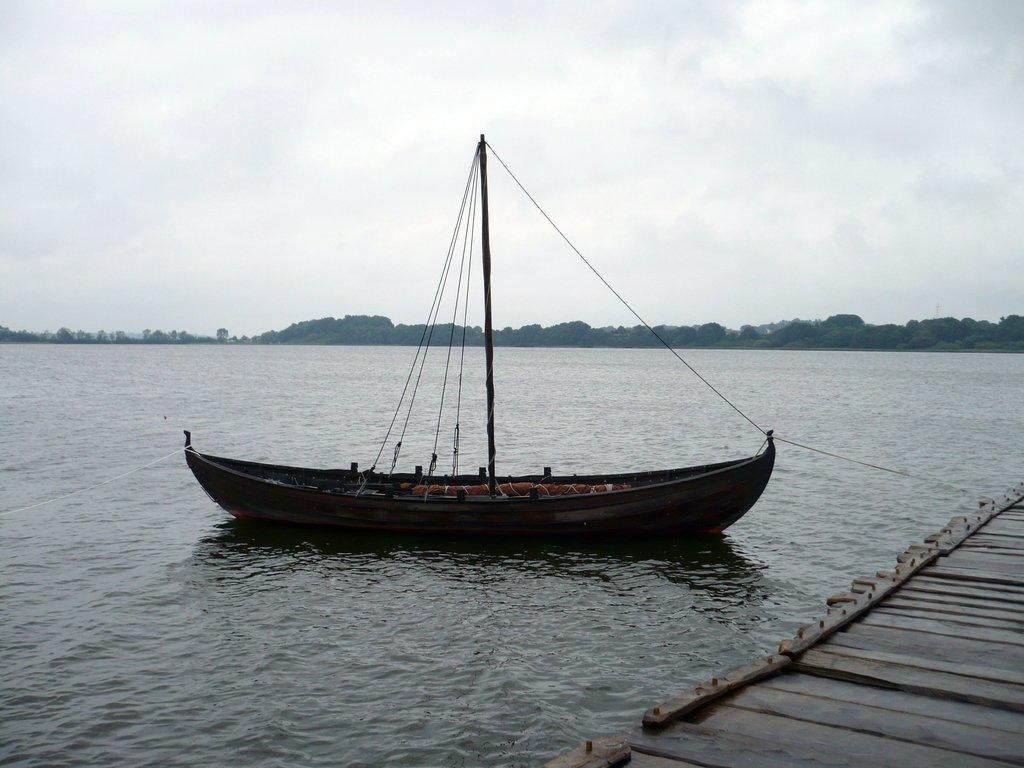What is the main subject of the image? The main subject of the image is a ship. What is the ship doing in the image? The ship is sailing on the water in the image. What can be seen in the background of the image? There are a few trees and the sky visible in the image. What type of pear is hanging from the trees in the image? There are no pears visible in the image; only a few trees can be seen in the background. 